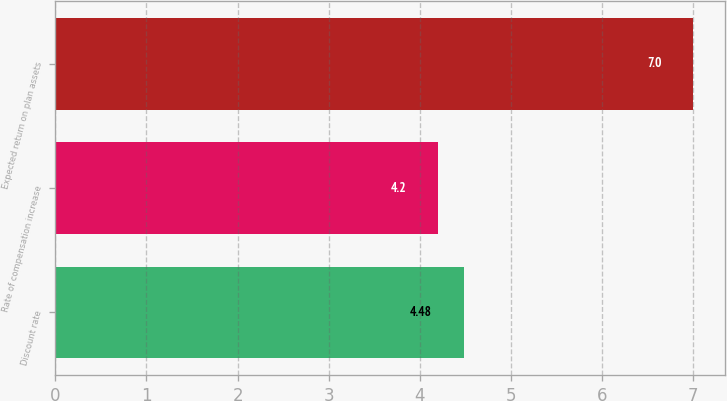<chart> <loc_0><loc_0><loc_500><loc_500><bar_chart><fcel>Discount rate<fcel>Rate of compensation increase<fcel>Expected return on plan assets<nl><fcel>4.48<fcel>4.2<fcel>7<nl></chart> 